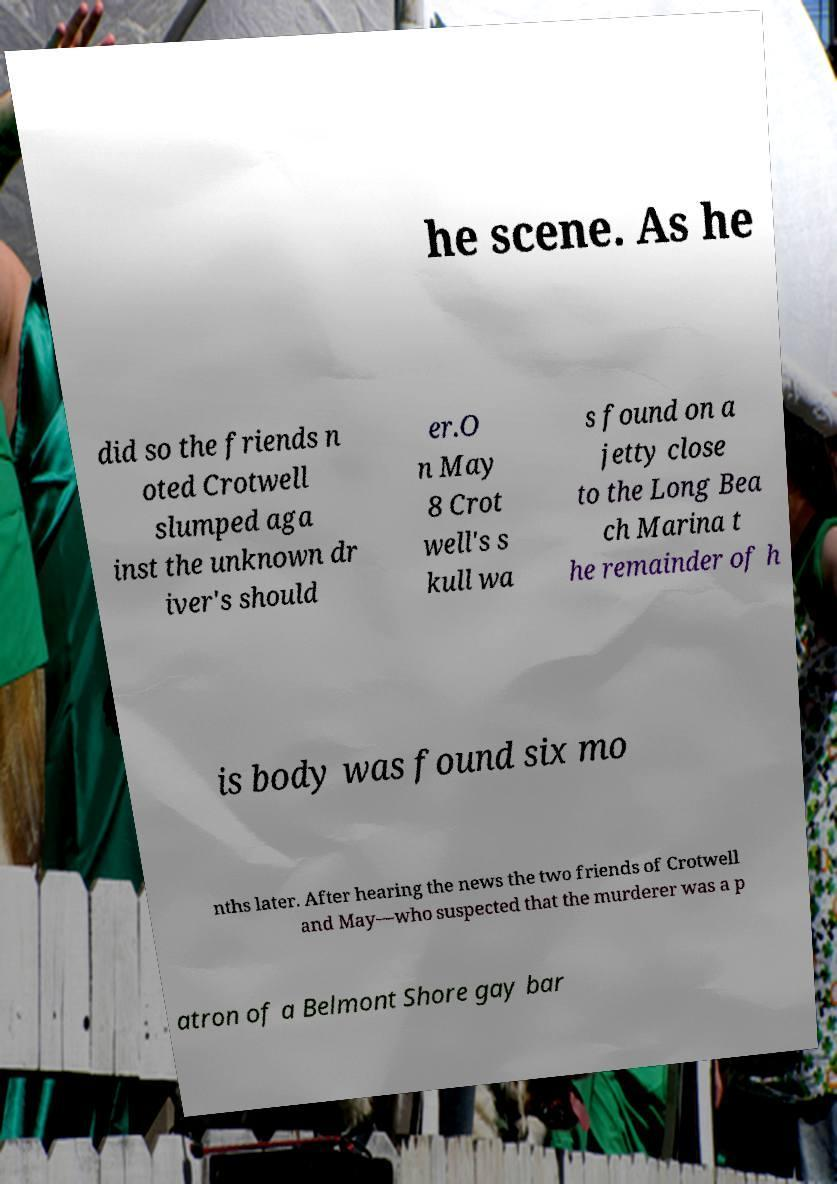Could you assist in decoding the text presented in this image and type it out clearly? he scene. As he did so the friends n oted Crotwell slumped aga inst the unknown dr iver's should er.O n May 8 Crot well's s kull wa s found on a jetty close to the Long Bea ch Marina t he remainder of h is body was found six mo nths later. After hearing the news the two friends of Crotwell and May—who suspected that the murderer was a p atron of a Belmont Shore gay bar 